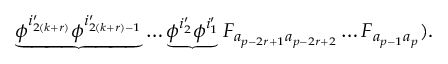Convert formula to latex. <formula><loc_0><loc_0><loc_500><loc_500>\underbrace { \phi ^ { i _ { 2 ( k + r ) } ^ { \prime } } \phi ^ { i _ { 2 ( k + r ) - 1 } ^ { \prime } } } \dots \underbrace { \phi ^ { i _ { 2 } ^ { \prime } } \phi ^ { i _ { 1 } ^ { \prime } } } F _ { a _ { p - 2 r + 1 } a _ { p - 2 r + 2 } } \dots F _ { a _ { p - 1 } a _ { p } } ) .</formula> 